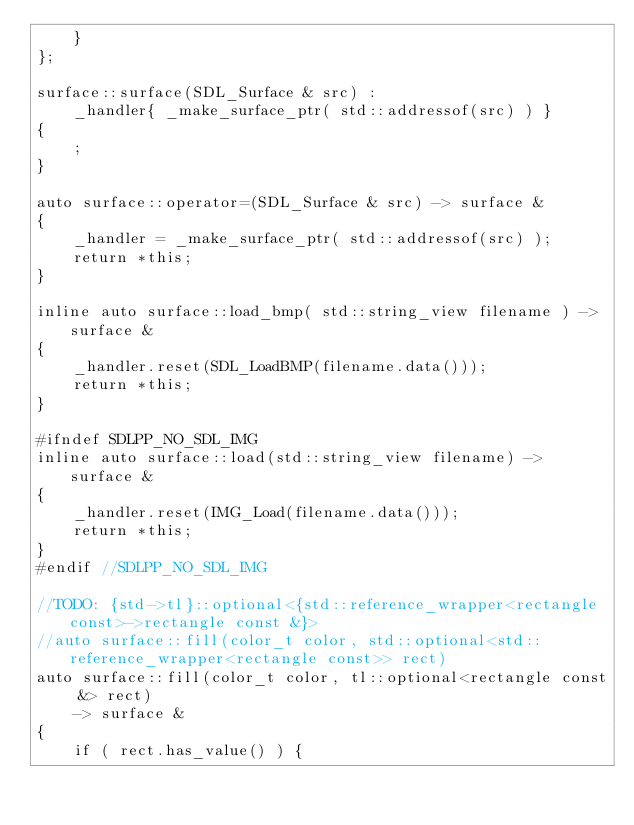<code> <loc_0><loc_0><loc_500><loc_500><_C++_>    }
};

surface::surface(SDL_Surface & src) :
    _handler{ _make_surface_ptr( std::addressof(src) ) }
{
    ;
}

auto surface::operator=(SDL_Surface & src) -> surface &
{
    _handler = _make_surface_ptr( std::addressof(src) );
    return *this;
}

inline auto surface::load_bmp( std::string_view filename ) -> surface &
{
    _handler.reset(SDL_LoadBMP(filename.data()));
    return *this;
}

#ifndef SDLPP_NO_SDL_IMG
inline auto surface::load(std::string_view filename) -> surface &
{
    _handler.reset(IMG_Load(filename.data()));
    return *this;
}
#endif //SDLPP_NO_SDL_IMG

//TODO: {std->tl}::optional<{std::reference_wrapper<rectangle const>->rectangle const &}>
//auto surface::fill(color_t color, std::optional<std::reference_wrapper<rectangle const>> rect)
auto surface::fill(color_t color, tl::optional<rectangle const &> rect)
    -> surface &
{
    if ( rect.has_value() ) {</code> 